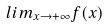<formula> <loc_0><loc_0><loc_500><loc_500>l i m _ { x \rightarrow + \infty } f ( x )</formula> 